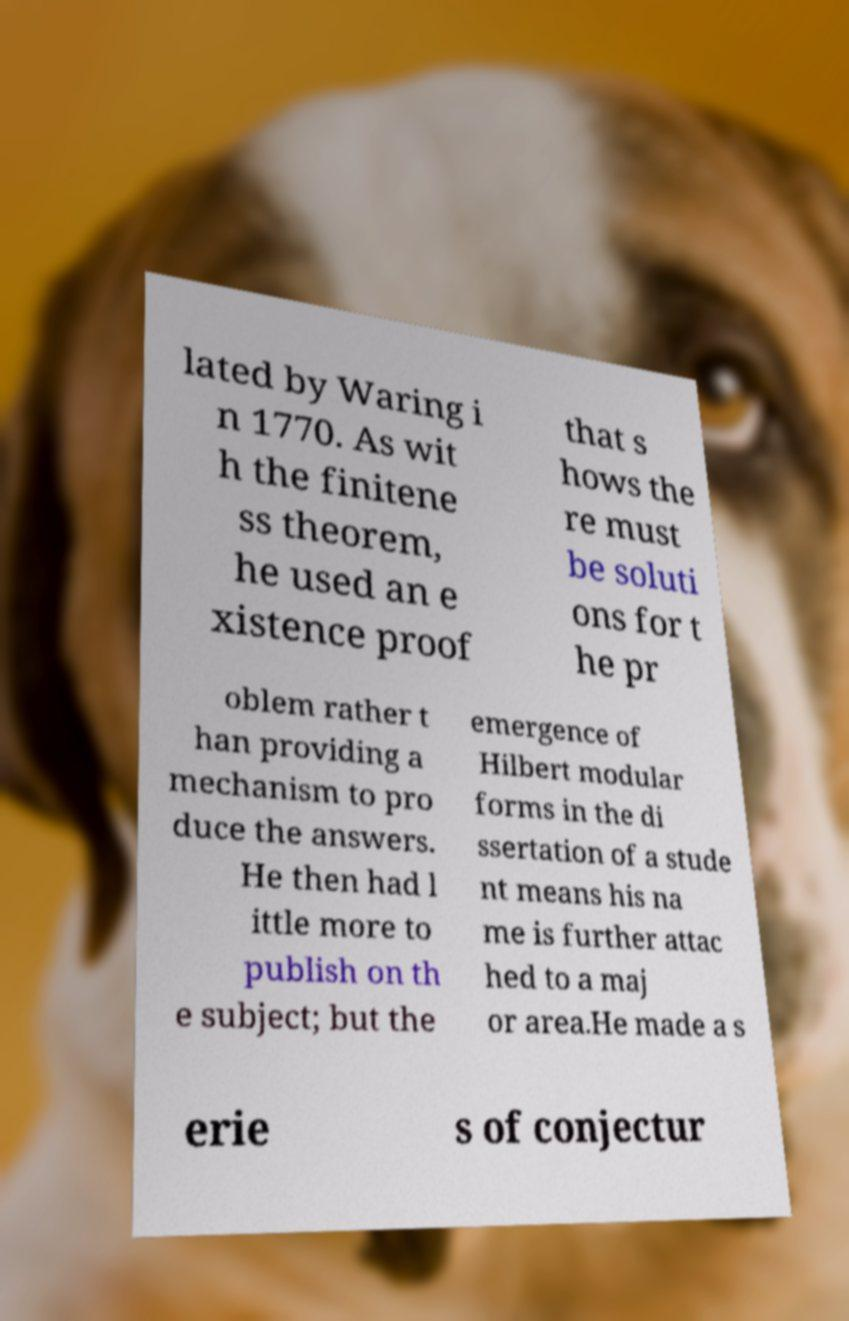I need the written content from this picture converted into text. Can you do that? lated by Waring i n 1770. As wit h the finitene ss theorem, he used an e xistence proof that s hows the re must be soluti ons for t he pr oblem rather t han providing a mechanism to pro duce the answers. He then had l ittle more to publish on th e subject; but the emergence of Hilbert modular forms in the di ssertation of a stude nt means his na me is further attac hed to a maj or area.He made a s erie s of conjectur 